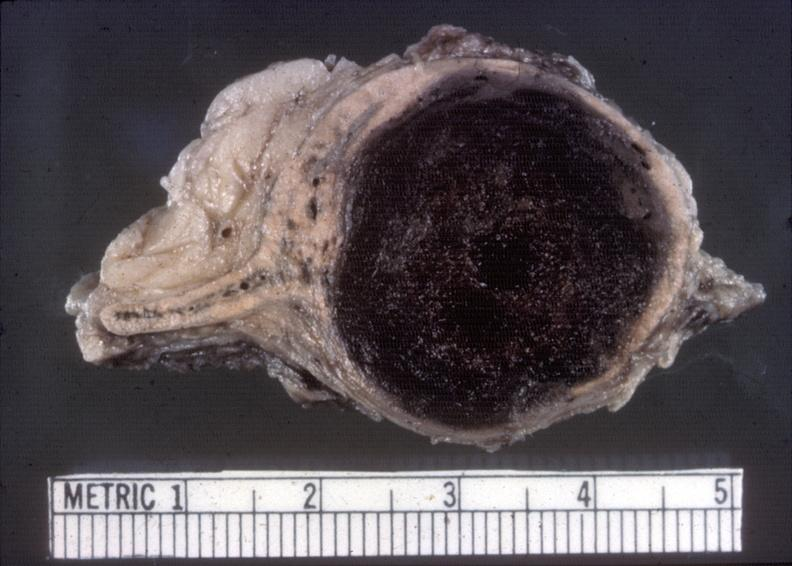does this image show adrenal, neuroblastoma?
Answer the question using a single word or phrase. Yes 